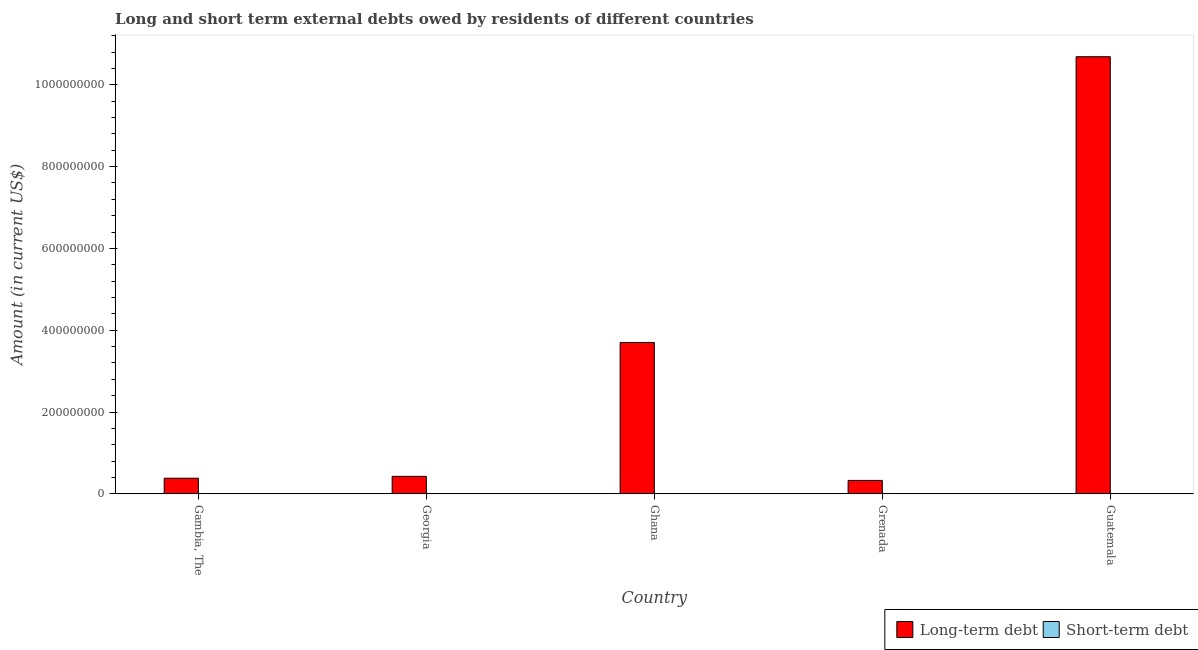Are the number of bars on each tick of the X-axis equal?
Provide a short and direct response. Yes. How many bars are there on the 3rd tick from the left?
Your answer should be compact. 1. What is the long-term debts owed by residents in Grenada?
Your answer should be very brief. 3.29e+07. Across all countries, what is the maximum long-term debts owed by residents?
Your answer should be very brief. 1.07e+09. Across all countries, what is the minimum long-term debts owed by residents?
Provide a succinct answer. 3.29e+07. What is the total long-term debts owed by residents in the graph?
Provide a short and direct response. 1.55e+09. What is the difference between the long-term debts owed by residents in Gambia, The and that in Grenada?
Offer a terse response. 5.40e+06. What is the difference between the short-term debts owed by residents in Gambia, The and the long-term debts owed by residents in Grenada?
Offer a terse response. -3.29e+07. What is the average short-term debts owed by residents per country?
Provide a short and direct response. 0. In how many countries, is the long-term debts owed by residents greater than 600000000 US$?
Your response must be concise. 1. What is the ratio of the long-term debts owed by residents in Georgia to that in Grenada?
Keep it short and to the point. 1.3. What is the difference between the highest and the second highest long-term debts owed by residents?
Offer a terse response. 6.98e+08. What is the difference between the highest and the lowest long-term debts owed by residents?
Give a very brief answer. 1.04e+09. In how many countries, is the long-term debts owed by residents greater than the average long-term debts owed by residents taken over all countries?
Provide a short and direct response. 2. Are the values on the major ticks of Y-axis written in scientific E-notation?
Keep it short and to the point. No. Does the graph contain grids?
Ensure brevity in your answer.  No. How many legend labels are there?
Your answer should be compact. 2. How are the legend labels stacked?
Provide a short and direct response. Horizontal. What is the title of the graph?
Keep it short and to the point. Long and short term external debts owed by residents of different countries. What is the label or title of the Y-axis?
Give a very brief answer. Amount (in current US$). What is the Amount (in current US$) of Long-term debt in Gambia, The?
Make the answer very short. 3.83e+07. What is the Amount (in current US$) in Short-term debt in Gambia, The?
Provide a short and direct response. 0. What is the Amount (in current US$) of Long-term debt in Georgia?
Provide a short and direct response. 4.28e+07. What is the Amount (in current US$) of Short-term debt in Georgia?
Keep it short and to the point. 0. What is the Amount (in current US$) in Long-term debt in Ghana?
Your answer should be compact. 3.70e+08. What is the Amount (in current US$) of Long-term debt in Grenada?
Keep it short and to the point. 3.29e+07. What is the Amount (in current US$) of Long-term debt in Guatemala?
Offer a very short reply. 1.07e+09. Across all countries, what is the maximum Amount (in current US$) in Long-term debt?
Make the answer very short. 1.07e+09. Across all countries, what is the minimum Amount (in current US$) of Long-term debt?
Provide a short and direct response. 3.29e+07. What is the total Amount (in current US$) of Long-term debt in the graph?
Provide a succinct answer. 1.55e+09. What is the difference between the Amount (in current US$) in Long-term debt in Gambia, The and that in Georgia?
Keep it short and to the point. -4.50e+06. What is the difference between the Amount (in current US$) of Long-term debt in Gambia, The and that in Ghana?
Your answer should be very brief. -3.32e+08. What is the difference between the Amount (in current US$) in Long-term debt in Gambia, The and that in Grenada?
Give a very brief answer. 5.40e+06. What is the difference between the Amount (in current US$) of Long-term debt in Gambia, The and that in Guatemala?
Offer a terse response. -1.03e+09. What is the difference between the Amount (in current US$) of Long-term debt in Georgia and that in Ghana?
Give a very brief answer. -3.27e+08. What is the difference between the Amount (in current US$) of Long-term debt in Georgia and that in Grenada?
Your response must be concise. 9.90e+06. What is the difference between the Amount (in current US$) of Long-term debt in Georgia and that in Guatemala?
Keep it short and to the point. -1.03e+09. What is the difference between the Amount (in current US$) of Long-term debt in Ghana and that in Grenada?
Make the answer very short. 3.37e+08. What is the difference between the Amount (in current US$) of Long-term debt in Ghana and that in Guatemala?
Ensure brevity in your answer.  -6.98e+08. What is the difference between the Amount (in current US$) in Long-term debt in Grenada and that in Guatemala?
Offer a very short reply. -1.04e+09. What is the average Amount (in current US$) in Long-term debt per country?
Give a very brief answer. 3.11e+08. What is the average Amount (in current US$) in Short-term debt per country?
Your response must be concise. 0. What is the ratio of the Amount (in current US$) of Long-term debt in Gambia, The to that in Georgia?
Make the answer very short. 0.89. What is the ratio of the Amount (in current US$) of Long-term debt in Gambia, The to that in Ghana?
Provide a succinct answer. 0.1. What is the ratio of the Amount (in current US$) of Long-term debt in Gambia, The to that in Grenada?
Keep it short and to the point. 1.16. What is the ratio of the Amount (in current US$) in Long-term debt in Gambia, The to that in Guatemala?
Provide a succinct answer. 0.04. What is the ratio of the Amount (in current US$) of Long-term debt in Georgia to that in Ghana?
Keep it short and to the point. 0.12. What is the ratio of the Amount (in current US$) in Long-term debt in Georgia to that in Grenada?
Provide a succinct answer. 1.3. What is the ratio of the Amount (in current US$) in Long-term debt in Georgia to that in Guatemala?
Ensure brevity in your answer.  0.04. What is the ratio of the Amount (in current US$) of Long-term debt in Ghana to that in Grenada?
Offer a very short reply. 11.26. What is the ratio of the Amount (in current US$) of Long-term debt in Ghana to that in Guatemala?
Provide a succinct answer. 0.35. What is the ratio of the Amount (in current US$) of Long-term debt in Grenada to that in Guatemala?
Provide a succinct answer. 0.03. What is the difference between the highest and the second highest Amount (in current US$) in Long-term debt?
Keep it short and to the point. 6.98e+08. What is the difference between the highest and the lowest Amount (in current US$) in Long-term debt?
Provide a short and direct response. 1.04e+09. 